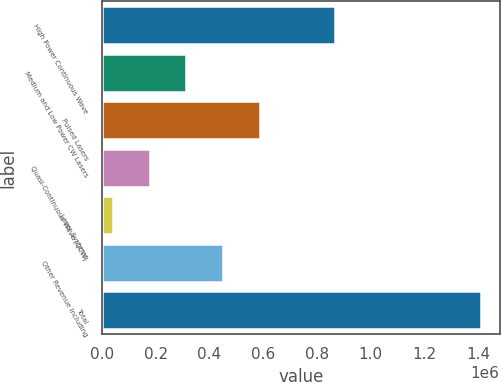<chart> <loc_0><loc_0><loc_500><loc_500><bar_chart><fcel>High Power Continuous Wave<fcel>Medium and Low Power CW Lasers<fcel>Pulsed Lasers<fcel>Quasi-Continuous Wave (QCW)<fcel>Laser Systems<fcel>Other Revenue including<fcel>Total<nl><fcel>867464<fcel>314106<fcel>587802<fcel>177258<fcel>40410<fcel>450954<fcel>1.40889e+06<nl></chart> 